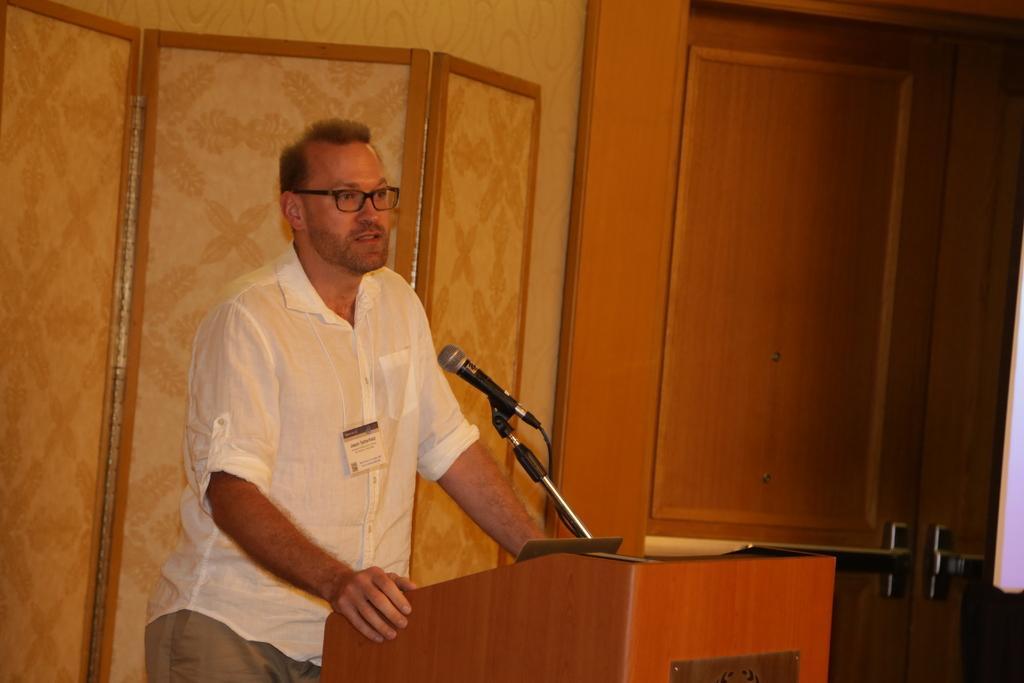Please provide a concise description of this image. In this image we can see one person wearing ID card, standing near to the podium and holding it. There is one microphone with stand, some objects are on the podium, one wall, one wooden door and some objects are on the surface. 